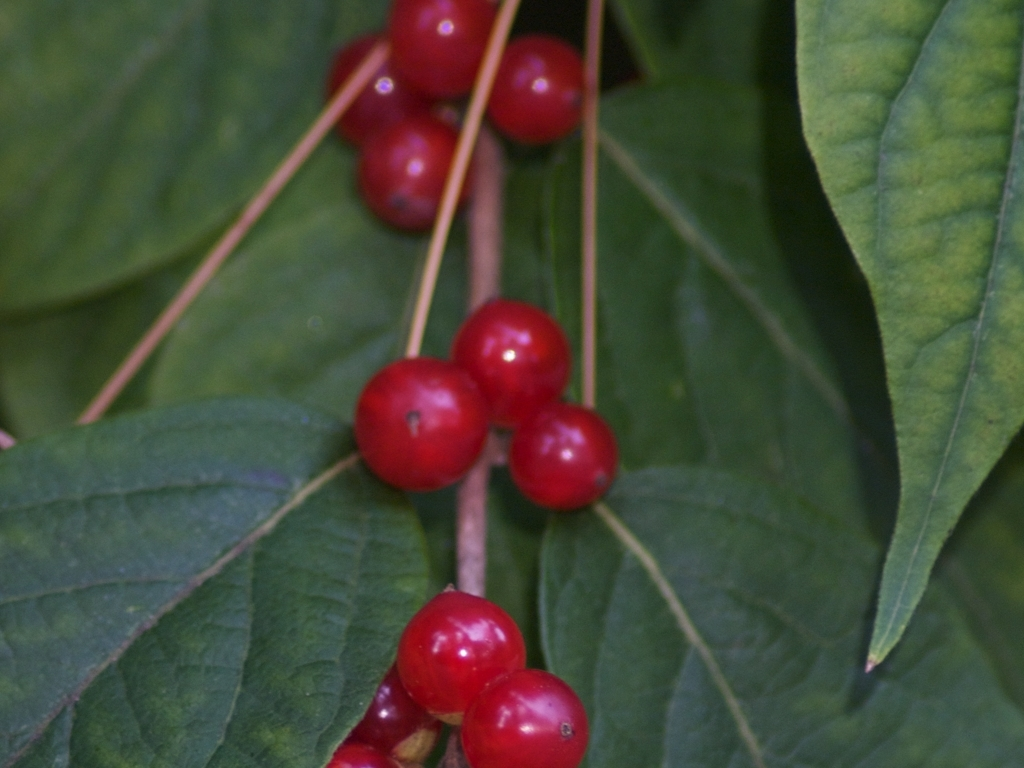Are these berries edible or poisonous? It's important to exercise caution with berries in nature, as appearances can be deceiving. Some berries that look appealing can indeed be poisonous. Identifying the exact species of the plant is crucial before consumption. If unsure, it's best to avoid eating them and consult with a local expert or a reliable field guide for edible plants. 